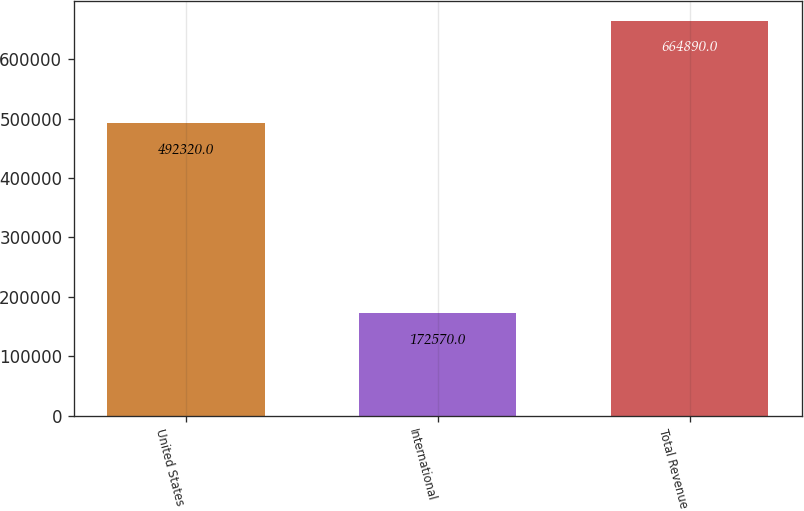Convert chart to OTSL. <chart><loc_0><loc_0><loc_500><loc_500><bar_chart><fcel>United States<fcel>International<fcel>Total Revenue<nl><fcel>492320<fcel>172570<fcel>664890<nl></chart> 